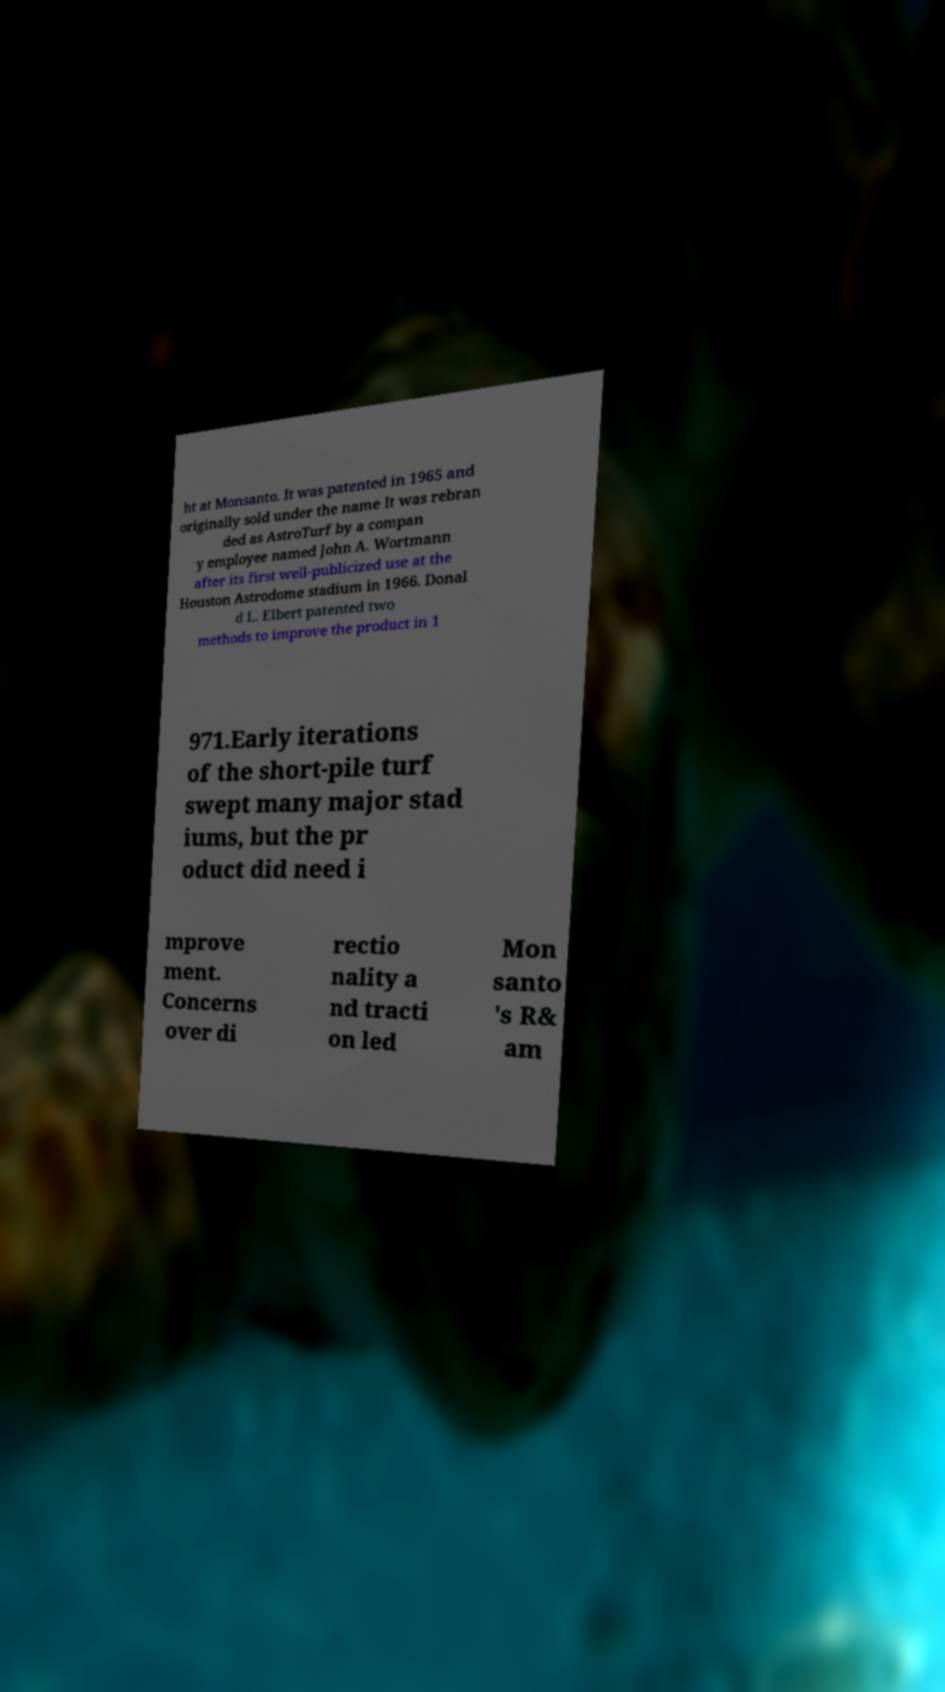Could you assist in decoding the text presented in this image and type it out clearly? ht at Monsanto. It was patented in 1965 and originally sold under the name It was rebran ded as AstroTurf by a compan y employee named John A. Wortmann after its first well-publicized use at the Houston Astrodome stadium in 1966. Donal d L. Elbert patented two methods to improve the product in 1 971.Early iterations of the short-pile turf swept many major stad iums, but the pr oduct did need i mprove ment. Concerns over di rectio nality a nd tracti on led Mon santo 's R& am 